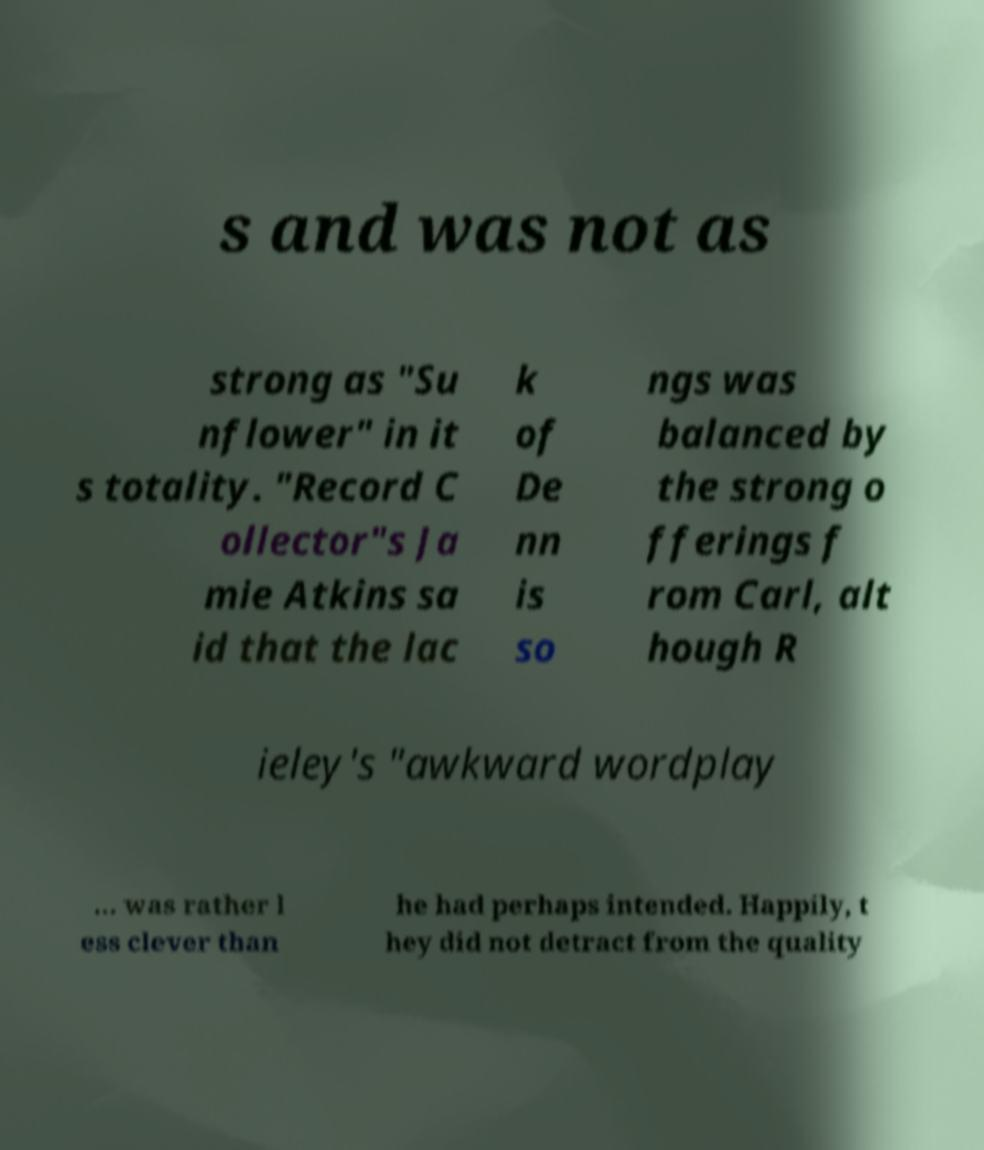Please read and relay the text visible in this image. What does it say? s and was not as strong as "Su nflower" in it s totality. "Record C ollector"s Ja mie Atkins sa id that the lac k of De nn is so ngs was balanced by the strong o fferings f rom Carl, alt hough R ieley's "awkward wordplay ... was rather l ess clever than he had perhaps intended. Happily, t hey did not detract from the quality 